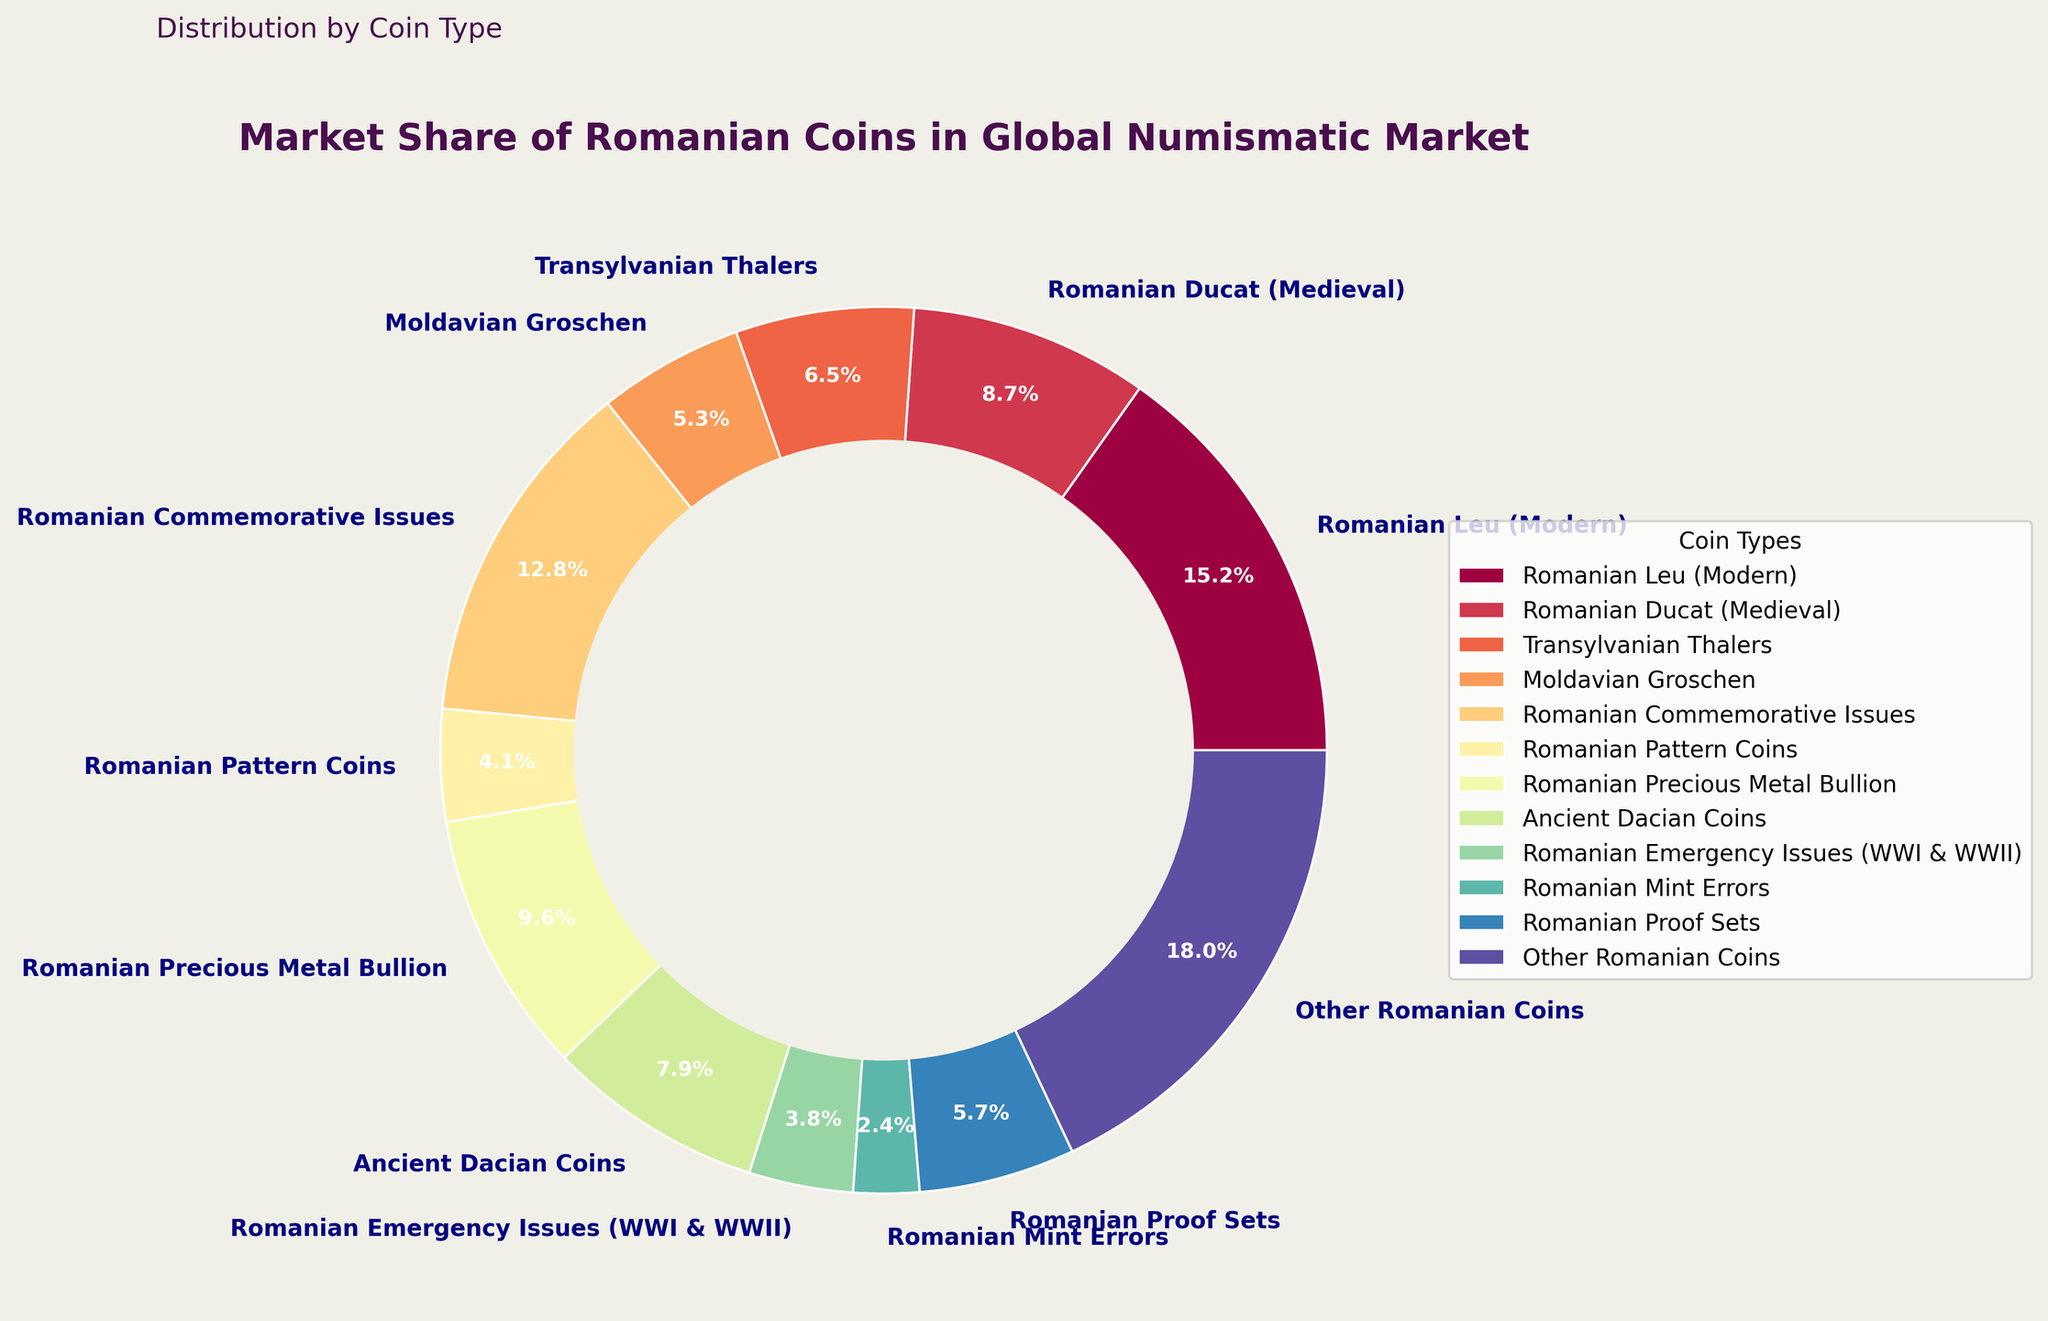Which coin type has the largest market share in the global numismatic market? Looking at the pie chart, the section labeled "Other Romanian Coins" occupies the largest portion of the chart.
Answer: Other Romanian Coins What's the combined market share of Romanian Leu (Modern) and Romanian Commemorative Issues? The market share of Romanian Leu (Modern) is 15.2% and Romanian Commemorative Issues is 12.8%. Adding these values together gives 15.2 + 12.8 = 28%.
Answer: 28% Which has a larger market share, Romanian Ducat (Medieval) or Transylvanian Thalers? Comparing the two segments, Romanian Ducat (Medieval) has a market share of 8.7% while Transylvanian Thalers stands at 6.5%.
Answer: Romanian Ducat (Medieval) By how much does the market share of Romanian Precious Metal Bullion exceed that of Romanian Mint Errors? Romanian Precious Metal Bullion has a market share of 9.6% and Romanian Mint Errors is 2.4%. Subtracting these values, 9.6 - 2.4 = 7.2%.
Answer: 7.2% Identify the coin types with a market share less than 5%. Examining the smaller sections of the pie chart, the coin types with a market share less than 5% are Romanian Pattern Coins (4.1%), Romanian Emergency Issues (3.8%), and Romanian Mint Errors (2.4%).
Answer: Romanian Pattern Coins, Romanian Emergency Issues, Romanian Mint Errors Which has a higher market share, Ancient Dacian Coins or Moldavian Groschen? Referring to the pie chart, Ancient Dacian Coins have a market share of 7.9%, while Moldavian Groschen have 5.3%.
Answer: Ancient Dacian Coins What's the total market share of all coin types with a market share greater than or equal to 10%? Adding the market share of coin types with percentages greater than or equal to 10%: Romanian Leu (Modern) (15.2%) and Other Romanian Coins (18%), the sum is 15.2 + 18 = 33.2%.
Answer: 33.2% What is the difference in market share between Romanian Proof Sets and Moldavian Groschen? Romanian Proof Sets have a market share of 5.7%, whereas Moldavian Groschen have 5.3%. Subtracting these values, 5.7 - 5.3 = 0.4%.
Answer: 0.4% How does the market share of Romanian Commemorative Issues compare to that of Romanian Precious Metal Bullion? Romanian Commemorative Issues have a market share of 12.8%, and Romanian Precious Metal Bullion has 9.6%. Comparing these values, Romanian Commemorative Issues has a higher percentage.
Answer: Romanian Commemorative Issues has a higher market share What is the average market share of the coin types with shares between 5% and 10% inclusively? Coin types in the range are Transylvanian Thalers (6.5%), Moldavian Groschen (5.3%), Ancient Dacian Coins (7.9%), and Romanian Proof Sets (5.7%). Their total market share is 6.5 + 5.3 + 7.9 + 5.7 = 25.4%. The average is 25.4 / 4 = 6.35%.
Answer: 6.35% 